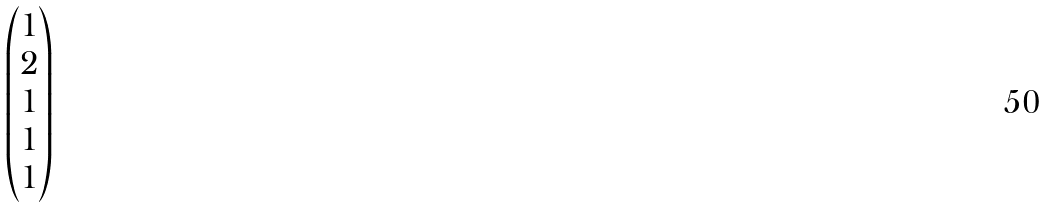<formula> <loc_0><loc_0><loc_500><loc_500>\begin{pmatrix} 1 \\ 2 \\ 1 \\ 1 \\ 1 \end{pmatrix}</formula> 